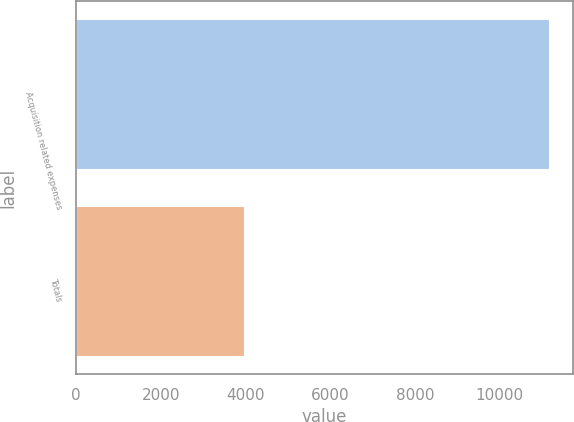Convert chart to OTSL. <chart><loc_0><loc_0><loc_500><loc_500><bar_chart><fcel>Acquisition related expenses<fcel>Totals<nl><fcel>11163<fcel>3957<nl></chart> 